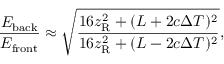<formula> <loc_0><loc_0><loc_500><loc_500>\frac { E _ { b a c k } } { E _ { f r o n t } } \approx \sqrt { \frac { 1 6 z _ { R } ^ { 2 } + ( L + 2 c \Delta T ) ^ { 2 } } { 1 6 z _ { R } ^ { 2 } + ( L - 2 c \Delta T ) ^ { 2 } } } ,</formula> 